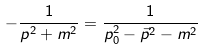Convert formula to latex. <formula><loc_0><loc_0><loc_500><loc_500>- \frac { 1 } { p ^ { 2 } + m ^ { 2 } } = \frac { 1 } { p _ { 0 } ^ { 2 } - \vec { p } ^ { 2 } - m ^ { 2 } }</formula> 